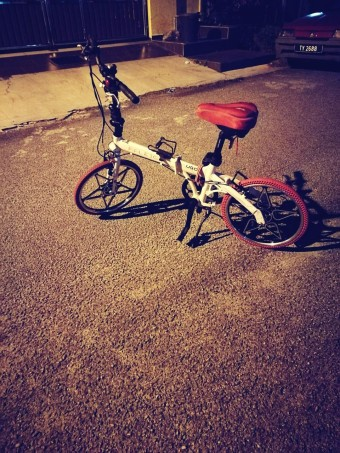Is there anything else interesting about the surroundings where the bicycle is parked? The surroundings hint at a quiet urban area, likely a residential neighborhood given the presence of a parked car in the background and the absence of commercial activity. The textured ground might suggest a well-used public space. 